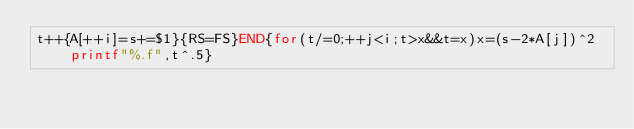<code> <loc_0><loc_0><loc_500><loc_500><_Awk_>t++{A[++i]=s+=$1}{RS=FS}END{for(t/=0;++j<i;t>x&&t=x)x=(s-2*A[j])^2printf"%.f",t^.5}</code> 